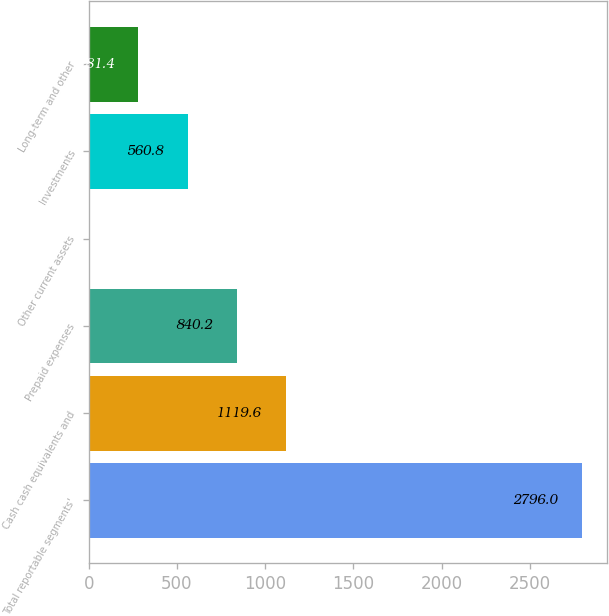Convert chart. <chart><loc_0><loc_0><loc_500><loc_500><bar_chart><fcel>Total reportable segments'<fcel>Cash cash equivalents and<fcel>Prepaid expenses<fcel>Other current assets<fcel>Investments<fcel>Long-term and other<nl><fcel>2796<fcel>1119.6<fcel>840.2<fcel>2<fcel>560.8<fcel>281.4<nl></chart> 